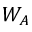Convert formula to latex. <formula><loc_0><loc_0><loc_500><loc_500>W _ { A }</formula> 